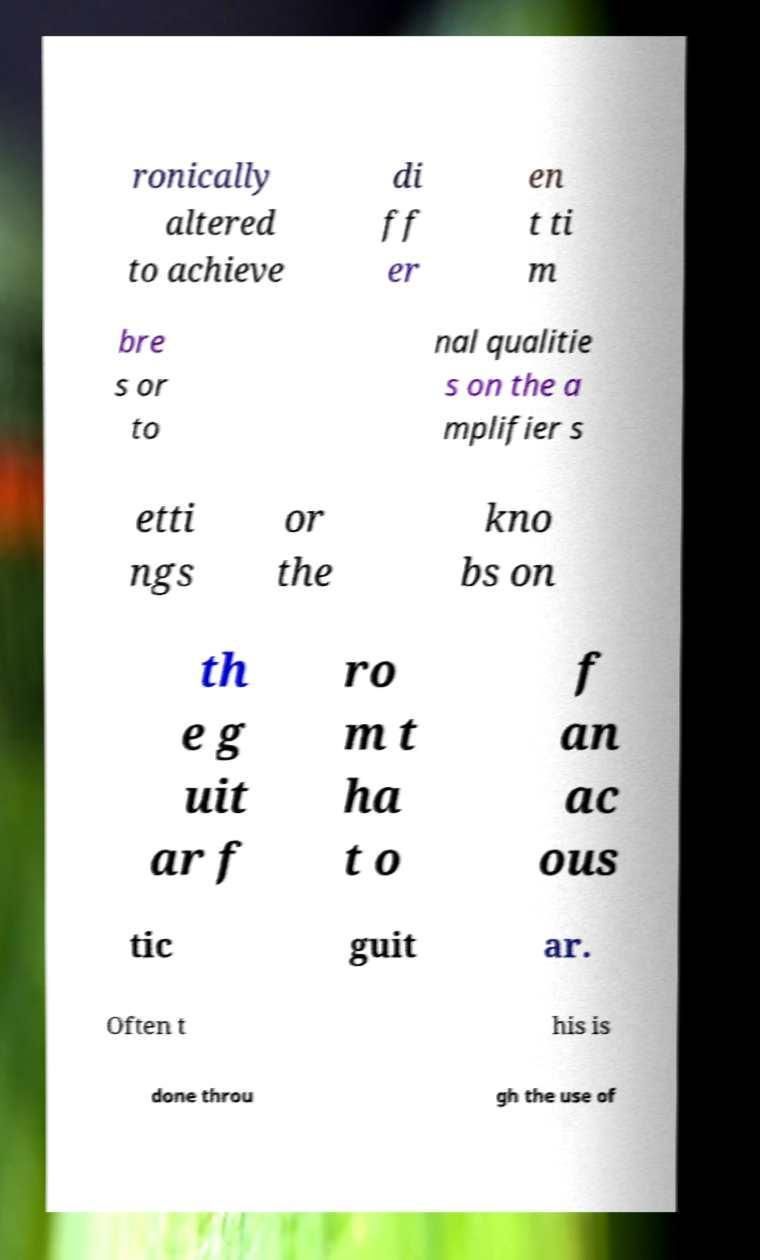For documentation purposes, I need the text within this image transcribed. Could you provide that? ronically altered to achieve di ff er en t ti m bre s or to nal qualitie s on the a mplifier s etti ngs or the kno bs on th e g uit ar f ro m t ha t o f an ac ous tic guit ar. Often t his is done throu gh the use of 